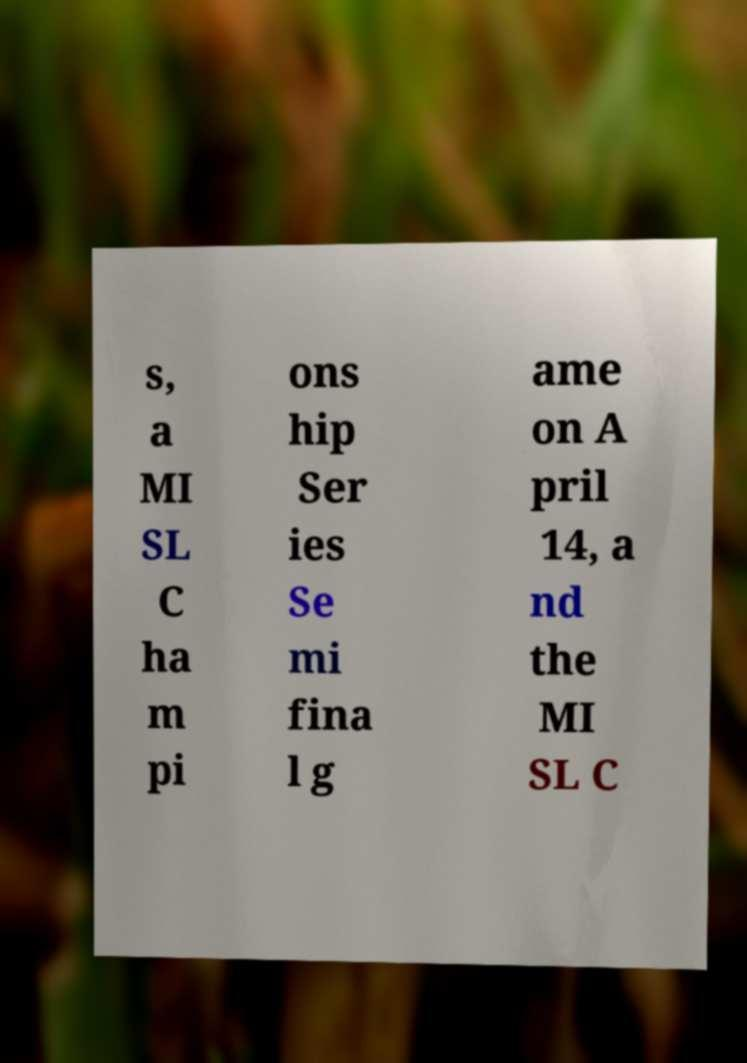I need the written content from this picture converted into text. Can you do that? s, a MI SL C ha m pi ons hip Ser ies Se mi fina l g ame on A pril 14, a nd the MI SL C 